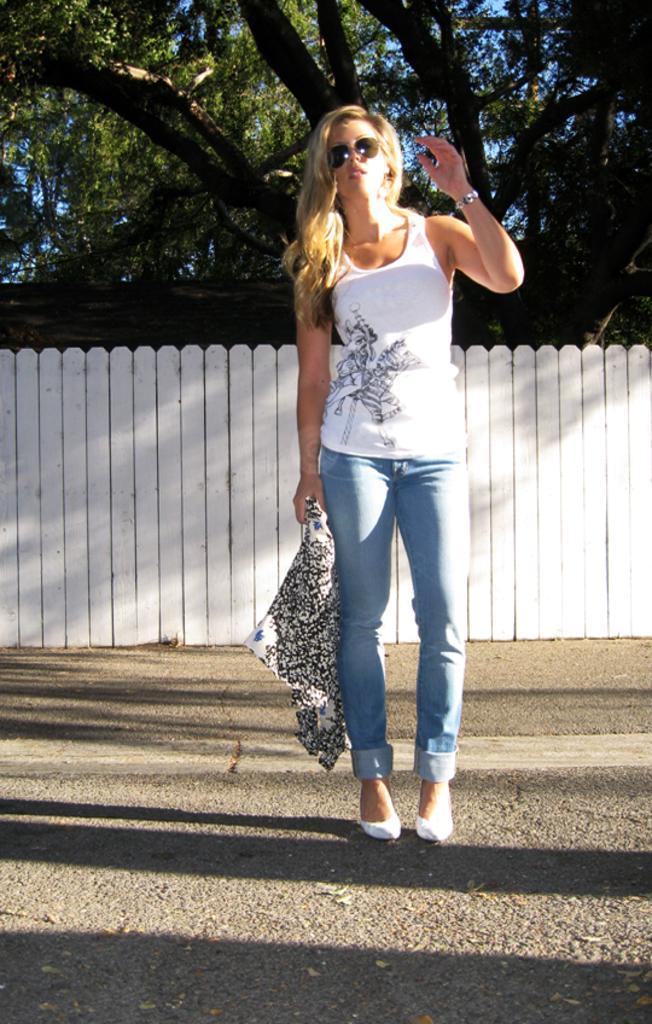Who is the main subject in the image? There is a woman in the center of the picture. Where is the woman located in the image? The woman is on the road. What can be seen in the background of the image? There is railing in the background of the image, and trees are visible behind the railing. How would you describe the weather in the image? The weather is sunny. What type of rake is the woman using to clear the road in the image? There is no rake present in the image, and the woman is not clearing the road. 